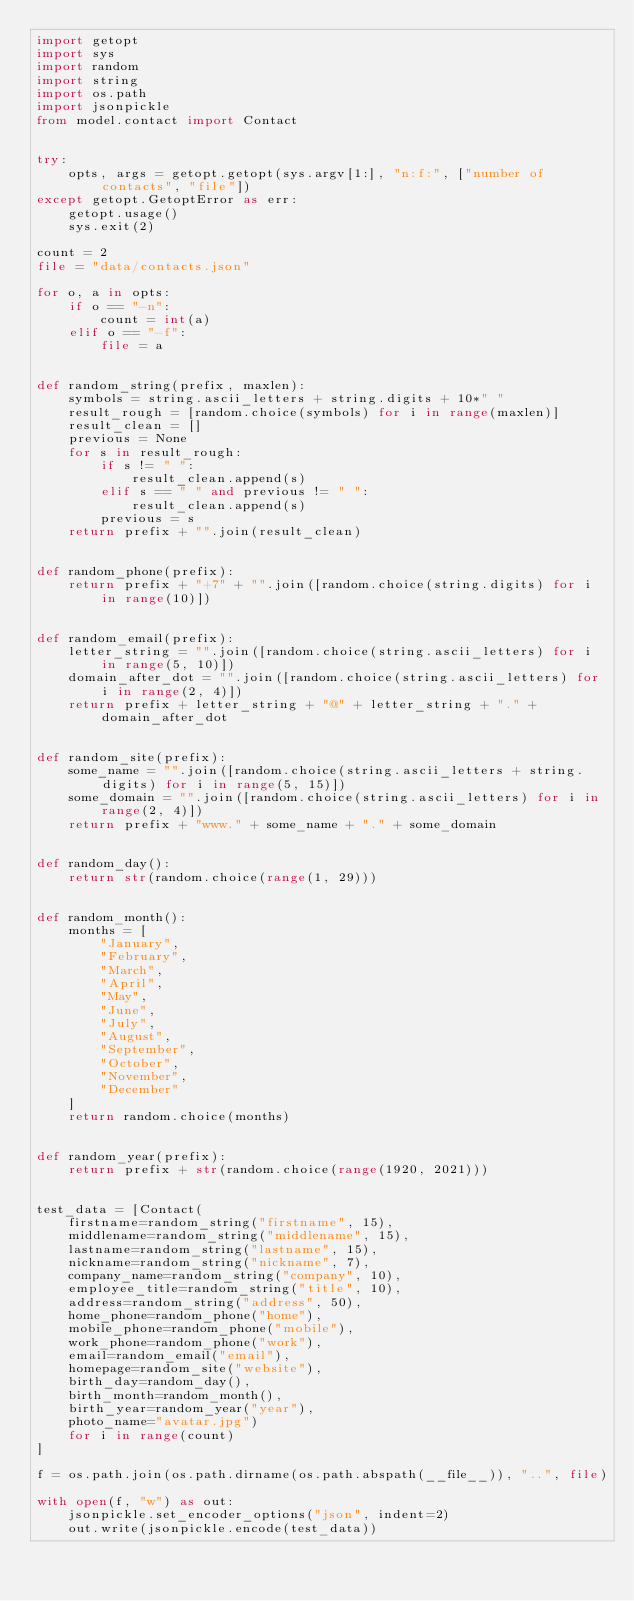Convert code to text. <code><loc_0><loc_0><loc_500><loc_500><_Python_>import getopt
import sys
import random
import string
import os.path
import jsonpickle
from model.contact import Contact


try:
    opts, args = getopt.getopt(sys.argv[1:], "n:f:", ["number of contacts", "file"])
except getopt.GetoptError as err:
    getopt.usage()
    sys.exit(2)

count = 2
file = "data/contacts.json"

for o, a in opts:
    if o == "-n":
        count = int(a)
    elif o == "-f":
        file = a


def random_string(prefix, maxlen):
    symbols = string.ascii_letters + string.digits + 10*" "
    result_rough = [random.choice(symbols) for i in range(maxlen)]
    result_clean = []
    previous = None
    for s in result_rough:
        if s != " ":
            result_clean.append(s)
        elif s == " " and previous != " ":
            result_clean.append(s)
        previous = s
    return prefix + "".join(result_clean)


def random_phone(prefix):
    return prefix + "+7" + "".join([random.choice(string.digits) for i in range(10)])


def random_email(prefix):
    letter_string = "".join([random.choice(string.ascii_letters) for i in range(5, 10)])
    domain_after_dot = "".join([random.choice(string.ascii_letters) for i in range(2, 4)])
    return prefix + letter_string + "@" + letter_string + "." + domain_after_dot


def random_site(prefix):
    some_name = "".join([random.choice(string.ascii_letters + string.digits) for i in range(5, 15)])
    some_domain = "".join([random.choice(string.ascii_letters) for i in range(2, 4)])
    return prefix + "www." + some_name + "." + some_domain


def random_day():
    return str(random.choice(range(1, 29)))


def random_month():
    months = [
        "January",
        "February",
        "March",
        "April",
        "May",
        "June",
        "July",
        "August",
        "September",
        "October",
        "November",
        "December"
    ]
    return random.choice(months)


def random_year(prefix):
    return prefix + str(random.choice(range(1920, 2021)))


test_data = [Contact(
    firstname=random_string("firstname", 15),
    middlename=random_string("middlename", 15),
    lastname=random_string("lastname", 15),
    nickname=random_string("nickname", 7),
    company_name=random_string("company", 10),
    employee_title=random_string("title", 10),
    address=random_string("address", 50),
    home_phone=random_phone("home"),
    mobile_phone=random_phone("mobile"),
    work_phone=random_phone("work"),
    email=random_email("email"),
    homepage=random_site("website"),
    birth_day=random_day(),
    birth_month=random_month(),
    birth_year=random_year("year"),
    photo_name="avatar.jpg")
    for i in range(count)
]

f = os.path.join(os.path.dirname(os.path.abspath(__file__)), "..", file)

with open(f, "w") as out:
    jsonpickle.set_encoder_options("json", indent=2)
    out.write(jsonpickle.encode(test_data))
</code> 